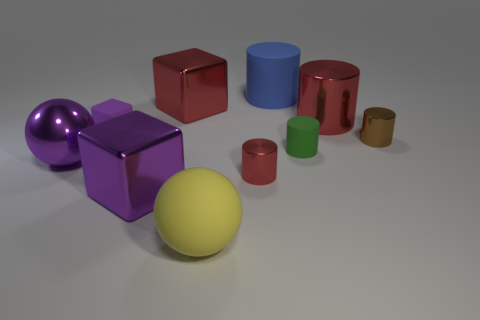Subtract all large rubber cylinders. How many cylinders are left? 4 Subtract all blue cylinders. How many cylinders are left? 4 Subtract 2 cylinders. How many cylinders are left? 3 Subtract all yellow cylinders. Subtract all yellow cubes. How many cylinders are left? 5 Subtract all blocks. How many objects are left? 7 Add 7 large blocks. How many large blocks are left? 9 Add 7 purple rubber cubes. How many purple rubber cubes exist? 8 Subtract 0 gray blocks. How many objects are left? 10 Subtract all shiny spheres. Subtract all tiny purple rubber cubes. How many objects are left? 8 